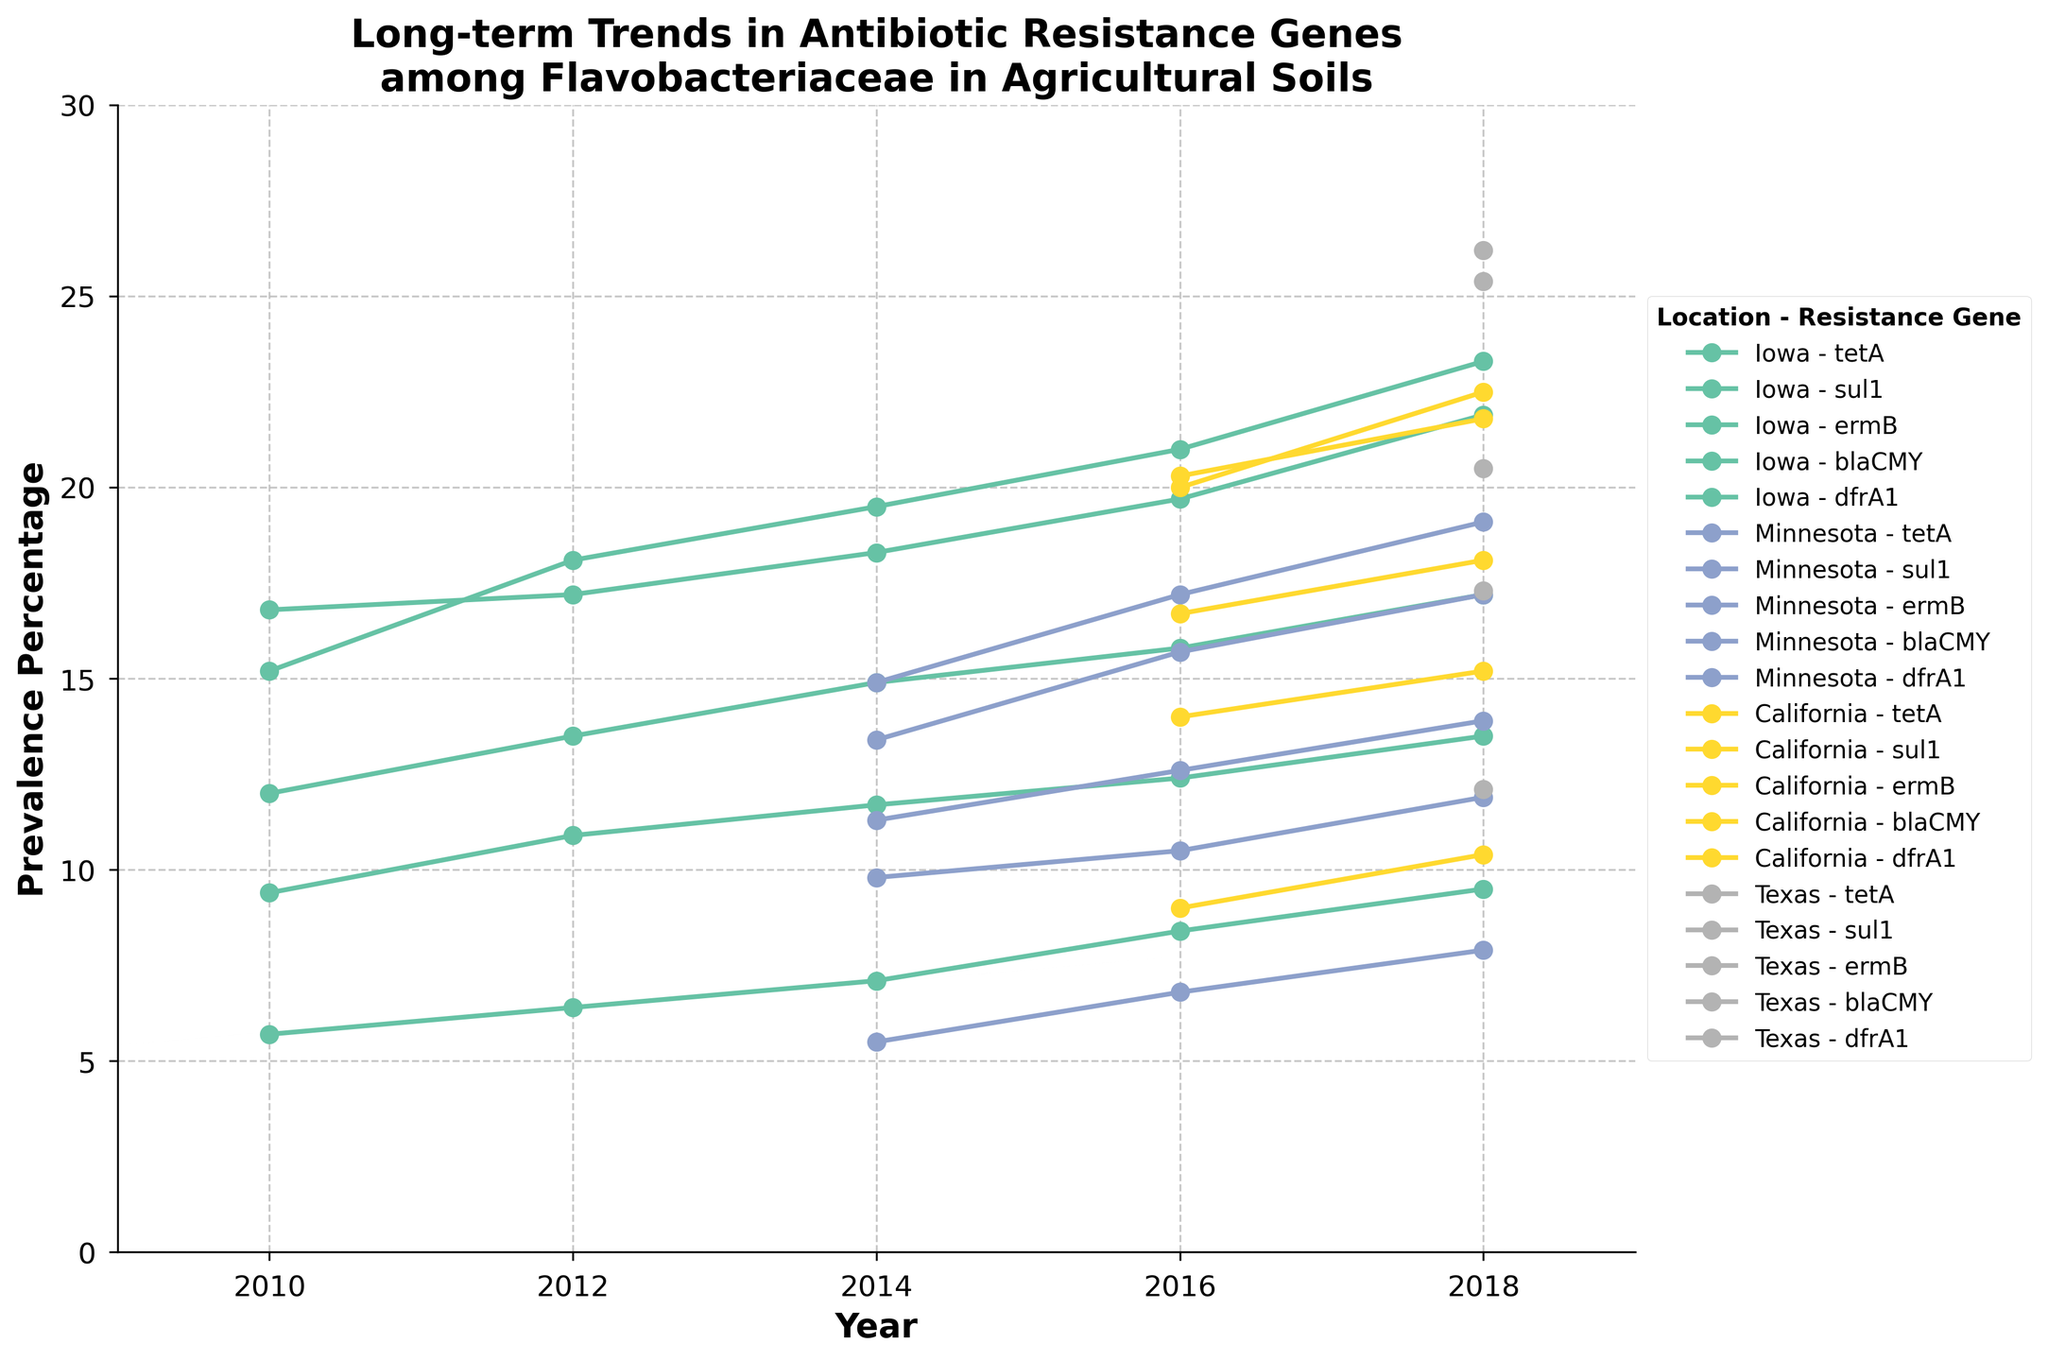What is the title of the plot? The title is located at the top of the plot and summarizes the main subject visually represented. It states "Long-term Trends in Antibiotic Resistance Genes among Flavobacteriaceae in Agricultural Soils."
Answer: Long-term Trends in Antibiotic Resistance Genes among Flavobacteriaceae in Agricultural Soils How many locations are represented in the plot? Each location has data points in different colors and is listed in the legend. Upon examining these colored segments, we find there are 4 unique locations represented: Iowa, Minnesota, California, and Texas.
Answer: 4 What is the highest prevalence percentage recorded for any antibiotic resistance gene in 2018, and in which location did it occur? From the legend and plot, we identify different prevalence percentages for 2018 and locate the highest data point. In 2018, the highest is 26.2% for sul1 in Texas.
Answer: 26.2% in Texas Which resistance gene shows the most significant increase in prevalence percentage in Iowa from 2010 to 2018? We track the prevalence percentages of each gene in Iowa and calculate the difference from 2010 to 2018. The tetA gene increases from 15.2% to 23.3%, which is the most significant rise.
Answer: tetA Compare the prevalence of the resistance gene ermB in Texas and California in 2018. Which location has a higher prevalence? Locate the ermB data points for 2018 in Texas and California. In 2018, Texas shows a higher prevalence of 17.3% compared to California's 15.2%.
Answer: Texas What is the average prevalence percentage of the resistance gene sul1 in Minnesota across all years? Identify the sul1 data points for Minnesota in all years: 2014 (14.9%), 2016 (17.2%), and 2018 (19.1%). Calculate the average: (14.9 + 17.2 + 19.1) / 3 = 17.07%
Answer: 17.07% Which location shows the highest overall prevalence of the tetA resistance gene in any year, and what is the percentage? Examine the data points for tetA across all years and locations. The highest is in Texas in 2018 with a prevalence of 25.4%.
Answer: Texas, 25.4% How does the prevalence of the blaCMY gene in Iowa change from 2010 to 2016? Observe the blaCMY points in Iowa for 2010 (5.7%) and 2016 (8.4%) and calculate the change: 8.4% - 5.7% = 2.7% increase.
Answer: Increase by 2.7% In which year did the average prevalence of resistance genes across all locations and resistance genes reach its peak? Calculate the average prevalence for each year considering all locations and genes. The year with the highest yearly average will be identified by summing individual prevalence percentages and dividing by the number of data points. The peak average is in 2018.
Answer: 2018 